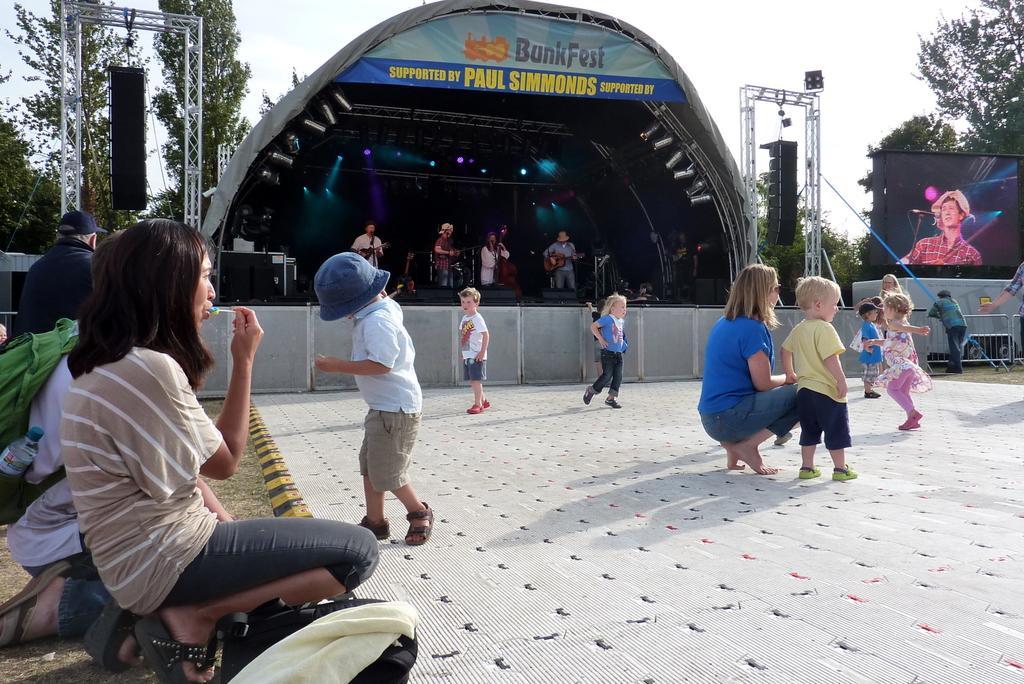Can you describe this image briefly? Here in this picture we can see number of children standing and walking on the ground over there and we can also see people standing and sitting over there and in the middle we can see a stage, on which we can see a group of band playing musical instruments present in their hand and we can see microphones on the stage and we can see speakers on the frames beside that, we can also see a digital screen on the right side and behind that we can see plants and trees present all over there. 